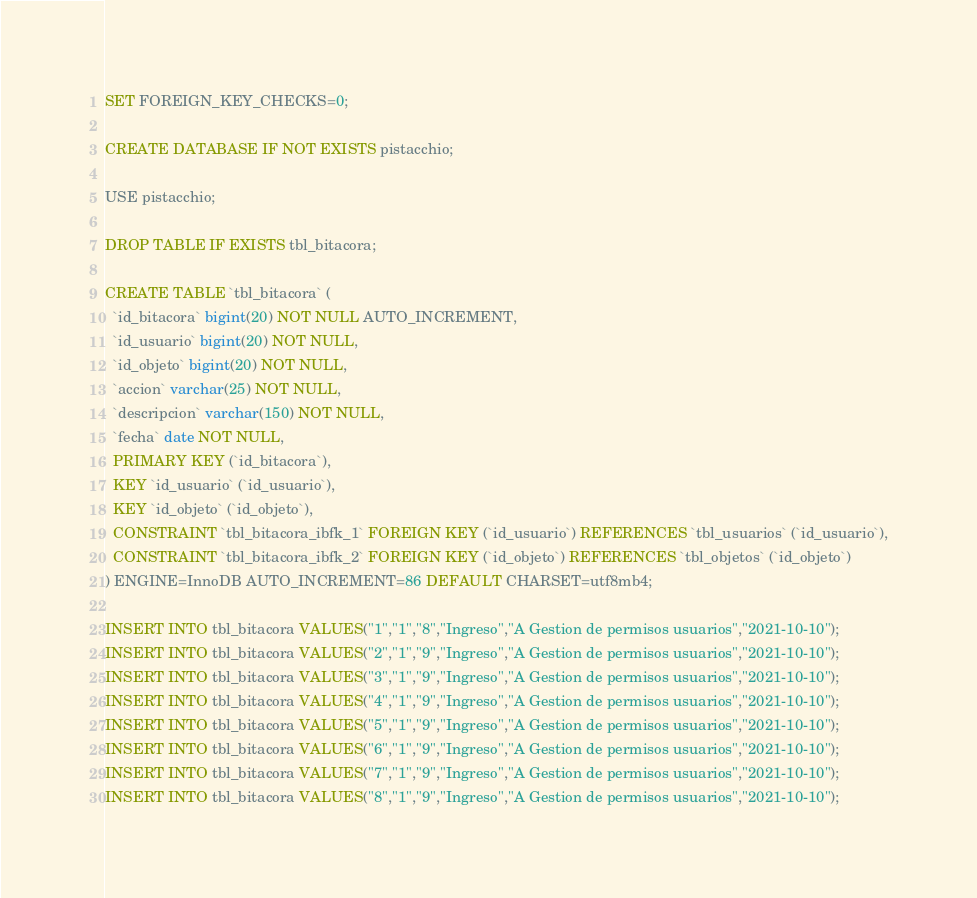<code> <loc_0><loc_0><loc_500><loc_500><_SQL_>SET FOREIGN_KEY_CHECKS=0;

CREATE DATABASE IF NOT EXISTS pistacchio;

USE pistacchio;

DROP TABLE IF EXISTS tbl_bitacora;

CREATE TABLE `tbl_bitacora` (
  `id_bitacora` bigint(20) NOT NULL AUTO_INCREMENT,
  `id_usuario` bigint(20) NOT NULL,
  `id_objeto` bigint(20) NOT NULL,
  `accion` varchar(25) NOT NULL,
  `descripcion` varchar(150) NOT NULL,
  `fecha` date NOT NULL,
  PRIMARY KEY (`id_bitacora`),
  KEY `id_usuario` (`id_usuario`),
  KEY `id_objeto` (`id_objeto`),
  CONSTRAINT `tbl_bitacora_ibfk_1` FOREIGN KEY (`id_usuario`) REFERENCES `tbl_usuarios` (`id_usuario`),
  CONSTRAINT `tbl_bitacora_ibfk_2` FOREIGN KEY (`id_objeto`) REFERENCES `tbl_objetos` (`id_objeto`)
) ENGINE=InnoDB AUTO_INCREMENT=86 DEFAULT CHARSET=utf8mb4;

INSERT INTO tbl_bitacora VALUES("1","1","8","Ingreso","A Gestion de permisos usuarios","2021-10-10");
INSERT INTO tbl_bitacora VALUES("2","1","9","Ingreso","A Gestion de permisos usuarios","2021-10-10");
INSERT INTO tbl_bitacora VALUES("3","1","9","Ingreso","A Gestion de permisos usuarios","2021-10-10");
INSERT INTO tbl_bitacora VALUES("4","1","9","Ingreso","A Gestion de permisos usuarios","2021-10-10");
INSERT INTO tbl_bitacora VALUES("5","1","9","Ingreso","A Gestion de permisos usuarios","2021-10-10");
INSERT INTO tbl_bitacora VALUES("6","1","9","Ingreso","A Gestion de permisos usuarios","2021-10-10");
INSERT INTO tbl_bitacora VALUES("7","1","9","Ingreso","A Gestion de permisos usuarios","2021-10-10");
INSERT INTO tbl_bitacora VALUES("8","1","9","Ingreso","A Gestion de permisos usuarios","2021-10-10");</code> 